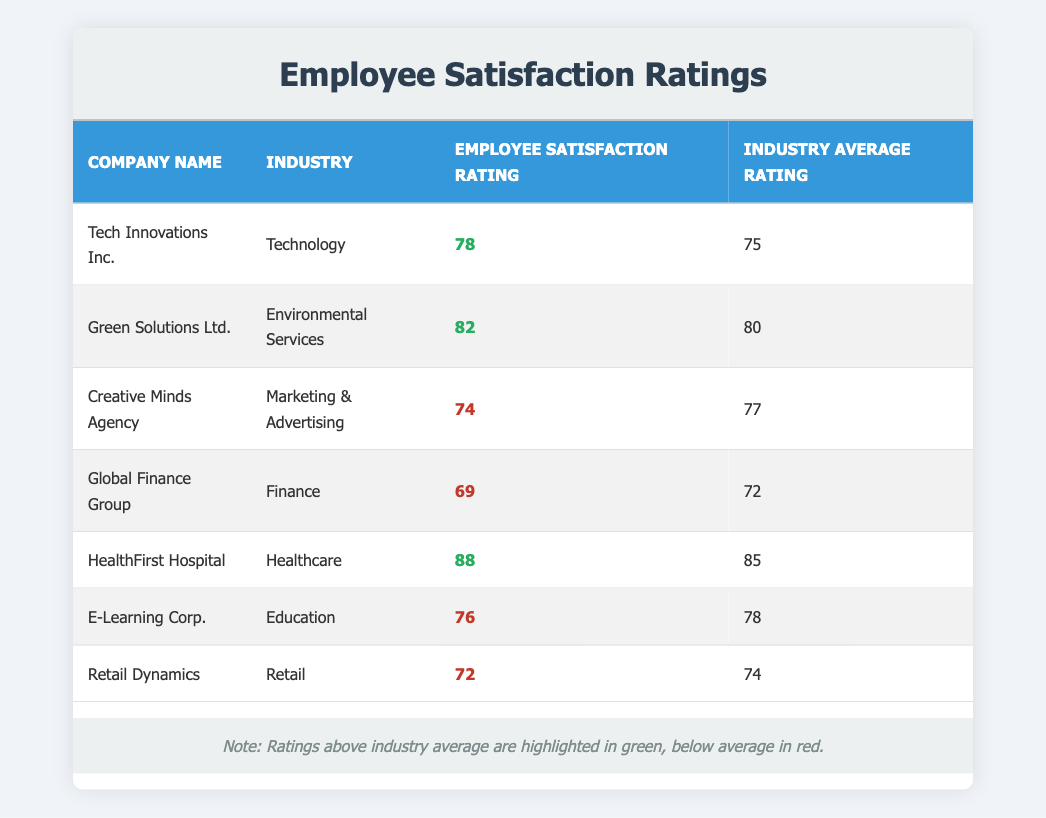What is the employee satisfaction rating for HealthFirst Hospital? According to the table, the employee satisfaction rating for HealthFirst Hospital is listed directly in the row corresponding to the company.
Answer: 88 Which company has the lowest employee satisfaction rating? By reviewing the employee satisfaction ratings in the table, the company with the lowest rating is Global Finance Group, which has a rating of 69.
Answer: Global Finance Group How much higher is the employee satisfaction rating of Green Solutions Ltd. compared to the industry average? For Green Solutions Ltd., the employee satisfaction rating is 82, and the industry average rating is 80. The difference is calculated as 82 - 80 = 2.
Answer: 2 Is the employee satisfaction rating of Tech Innovations Inc. above the industry average? Looking at the employee satisfaction rating for Tech Innovations Inc. (78) and the industry average rating (75), we can determine that 78 is greater than 75.
Answer: Yes What is the average employee satisfaction rating for the companies in the table? First, sum the employee satisfaction ratings: 78 + 82 + 74 + 69 + 88 + 76 + 72 = 539. There are 7 companies, so the average is 539 / 7 = 77.
Answer: 77 Which industry has an employee satisfaction rating that is below the industry average? By comparing each company's rating with their respective industry averages, Creative Minds Agency (74 vs. 77) and Global Finance Group (69 vs. 72) both have below-average ratings.
Answer: Creative Minds Agency and Global Finance Group Which company has an employee satisfaction rating exactly equal to the industry average? Upon examining the table, none of the companies have an employee satisfaction rating that matches their industry average, as all ratings either exceed or fall short of the average.
Answer: None Which company exceeds the industry average by the greatest margin? We need to find the differences: Tech Innovations Inc. (3), Green Solutions Ltd. (2), HealthFirst Hospital (3). Both HealthFirst Hospital and Tech Innovations Inc. have the greatest margin of 3 above their respective averages.
Answer: Tech Innovations Inc. and HealthFirst Hospital How many companies have an employee satisfaction rating above 75? By examining the ratings in the table, the companies with ratings above 75 are Tech Innovations Inc., Green Solutions Ltd., and HealthFirst Hospital. That totals to three companies.
Answer: 3 